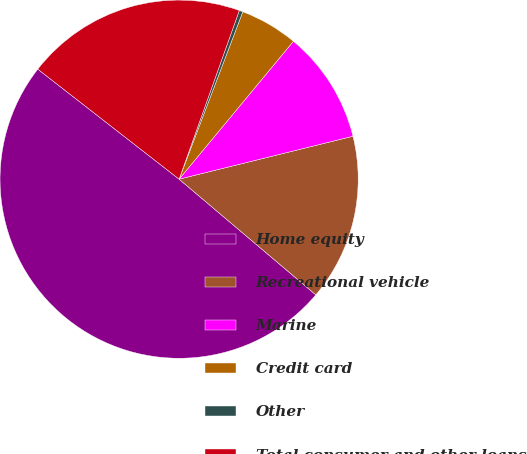<chart> <loc_0><loc_0><loc_500><loc_500><pie_chart><fcel>Home equity<fcel>Recreational vehicle<fcel>Marine<fcel>Credit card<fcel>Other<fcel>Total consumer and other loans<nl><fcel>49.35%<fcel>15.03%<fcel>10.13%<fcel>5.23%<fcel>0.33%<fcel>19.93%<nl></chart> 